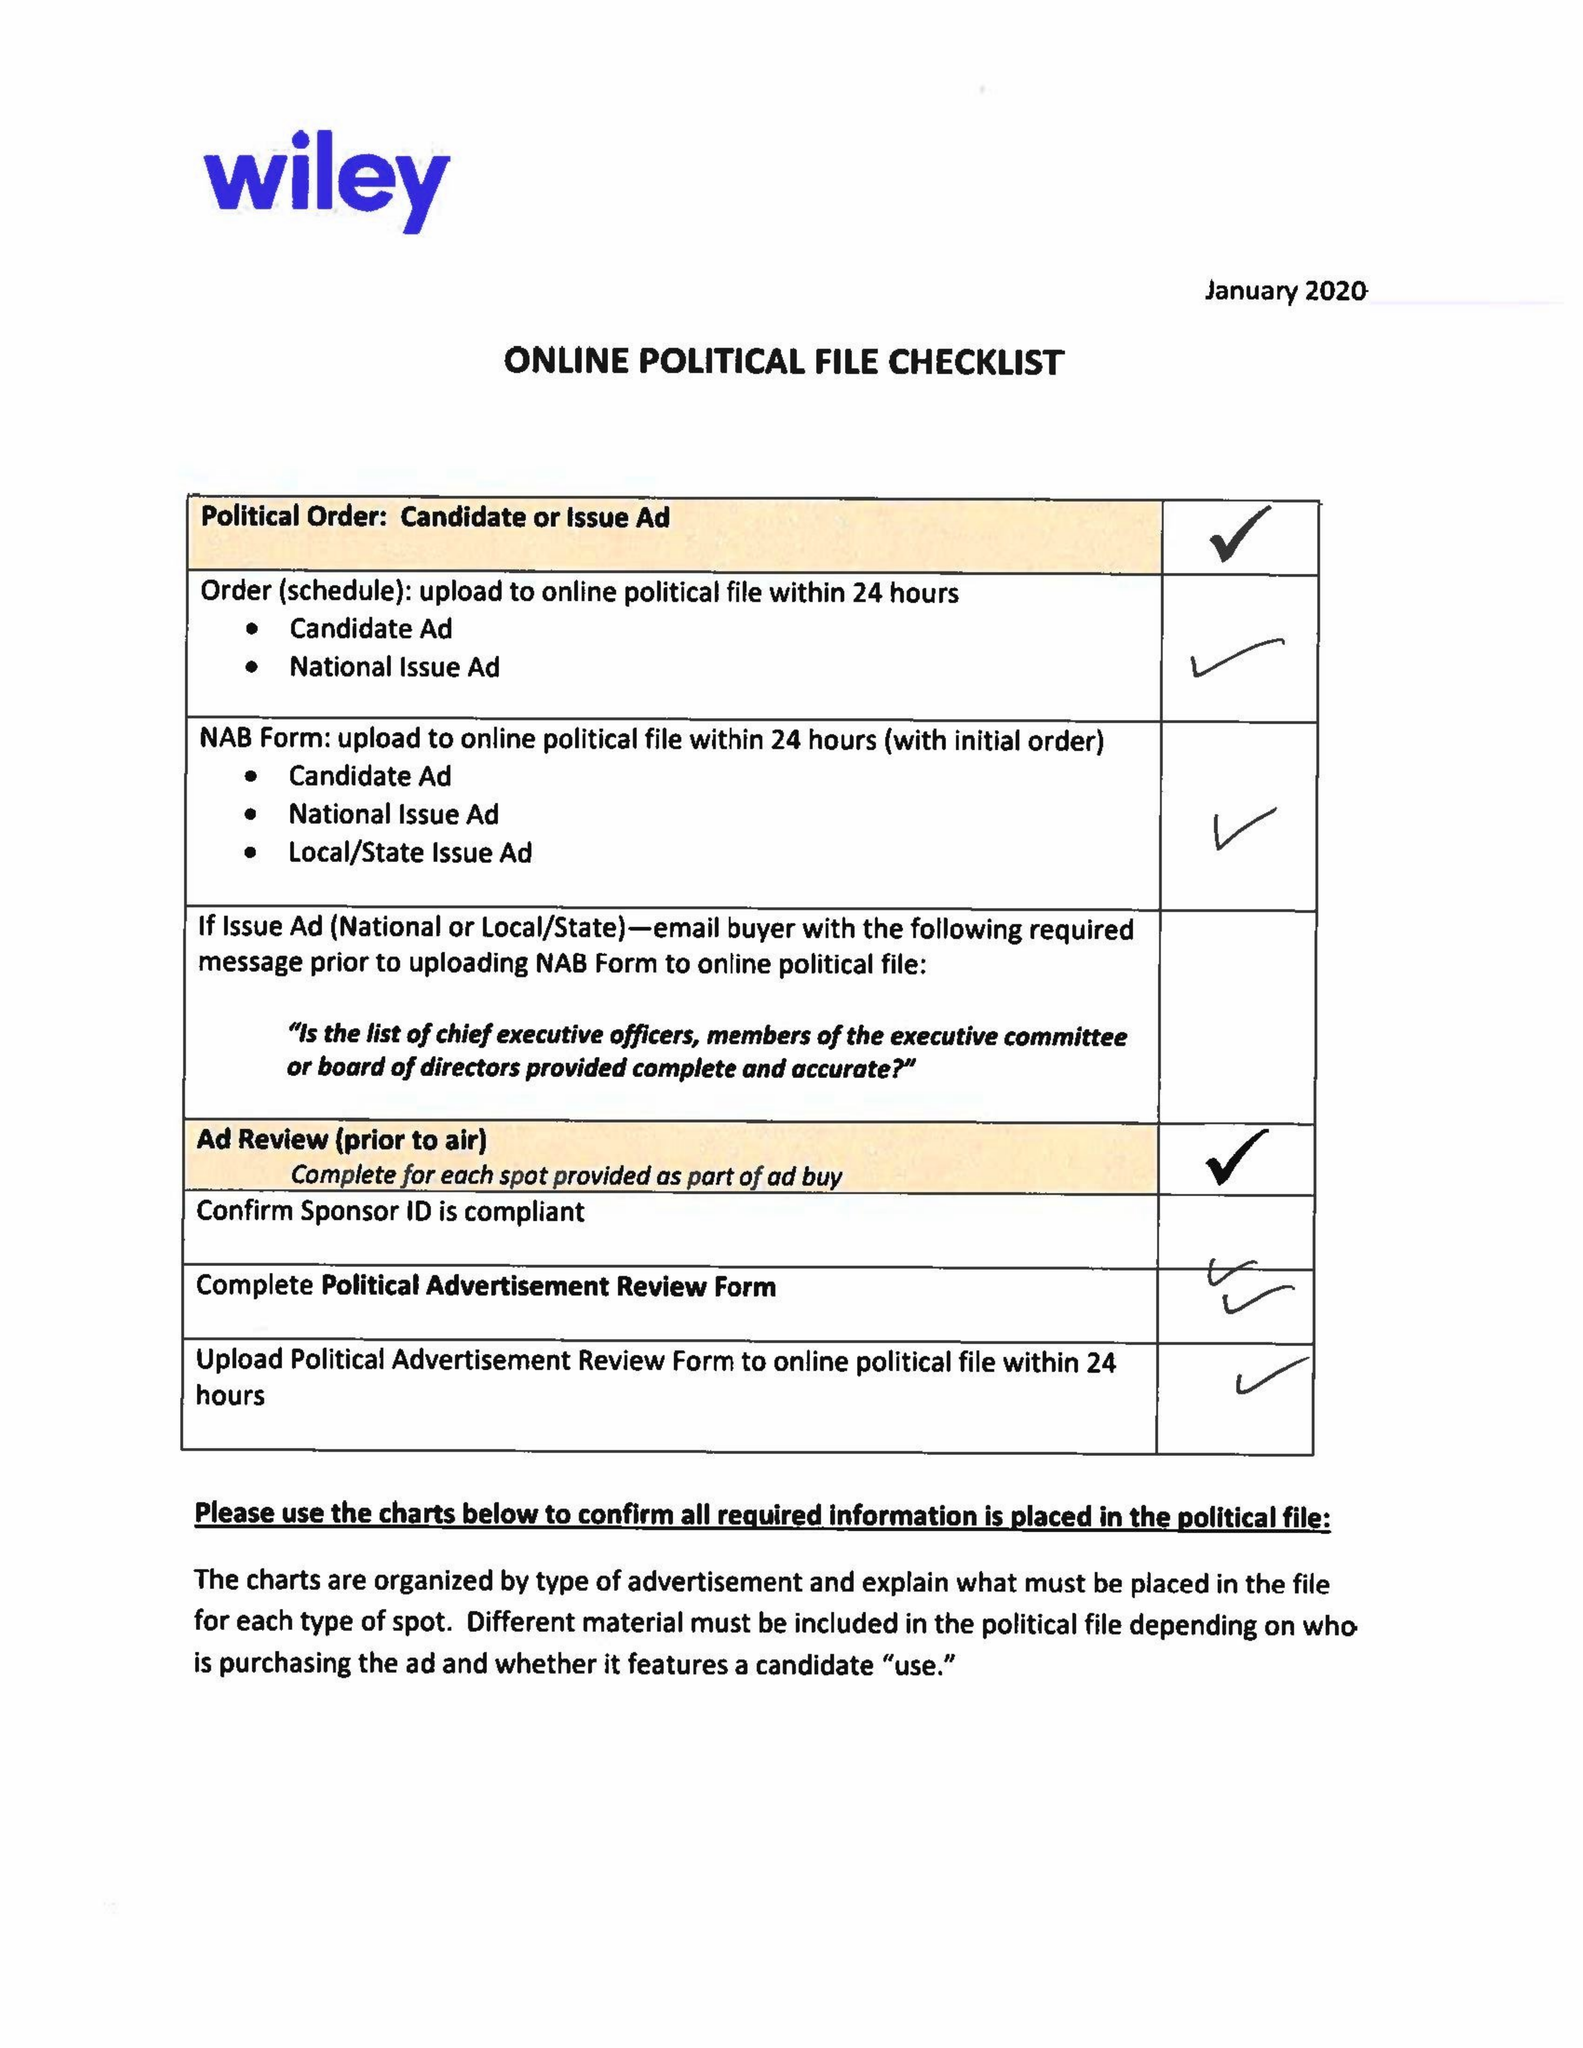What is the value for the flight_to?
Answer the question using a single word or phrase. 02/11/20 